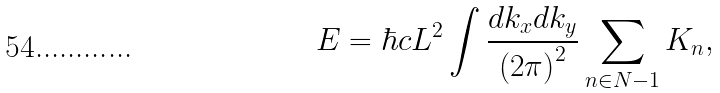Convert formula to latex. <formula><loc_0><loc_0><loc_500><loc_500>E = \hbar { c } L ^ { 2 } \int \frac { d k _ { x } d k _ { y } } { \left ( 2 \pi \right ) ^ { 2 } } \sum _ { n \in N - 1 } K _ { n } ,</formula> 